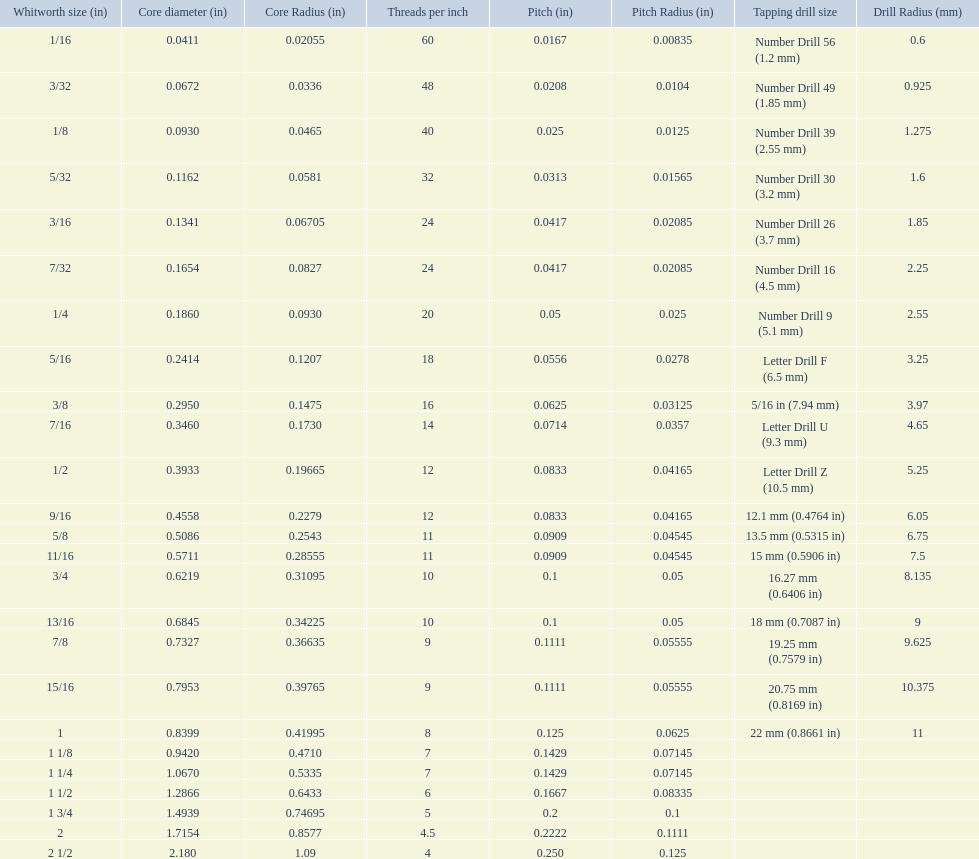What is the top amount of threads per inch? 60. 